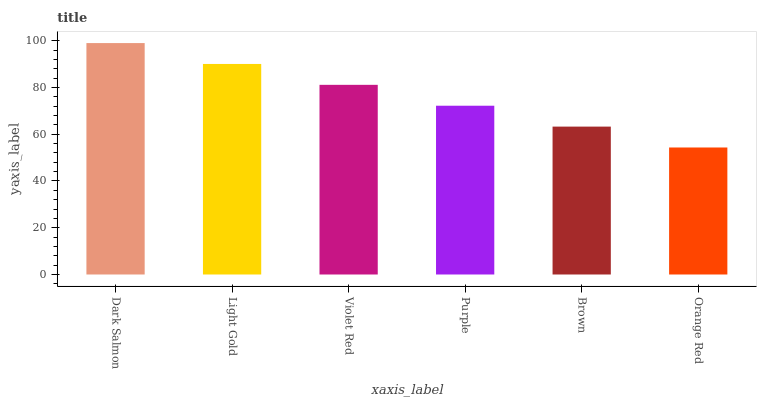Is Orange Red the minimum?
Answer yes or no. Yes. Is Dark Salmon the maximum?
Answer yes or no. Yes. Is Light Gold the minimum?
Answer yes or no. No. Is Light Gold the maximum?
Answer yes or no. No. Is Dark Salmon greater than Light Gold?
Answer yes or no. Yes. Is Light Gold less than Dark Salmon?
Answer yes or no. Yes. Is Light Gold greater than Dark Salmon?
Answer yes or no. No. Is Dark Salmon less than Light Gold?
Answer yes or no. No. Is Violet Red the high median?
Answer yes or no. Yes. Is Purple the low median?
Answer yes or no. Yes. Is Brown the high median?
Answer yes or no. No. Is Light Gold the low median?
Answer yes or no. No. 